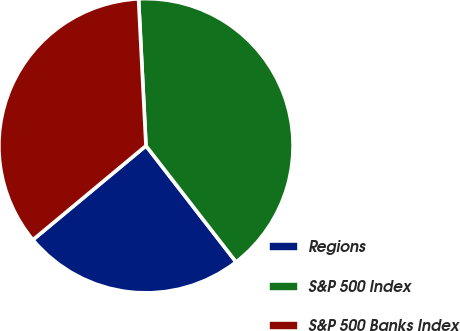<chart> <loc_0><loc_0><loc_500><loc_500><pie_chart><fcel>Regions<fcel>S&P 500 Index<fcel>S&P 500 Banks Index<nl><fcel>24.45%<fcel>40.31%<fcel>35.24%<nl></chart> 